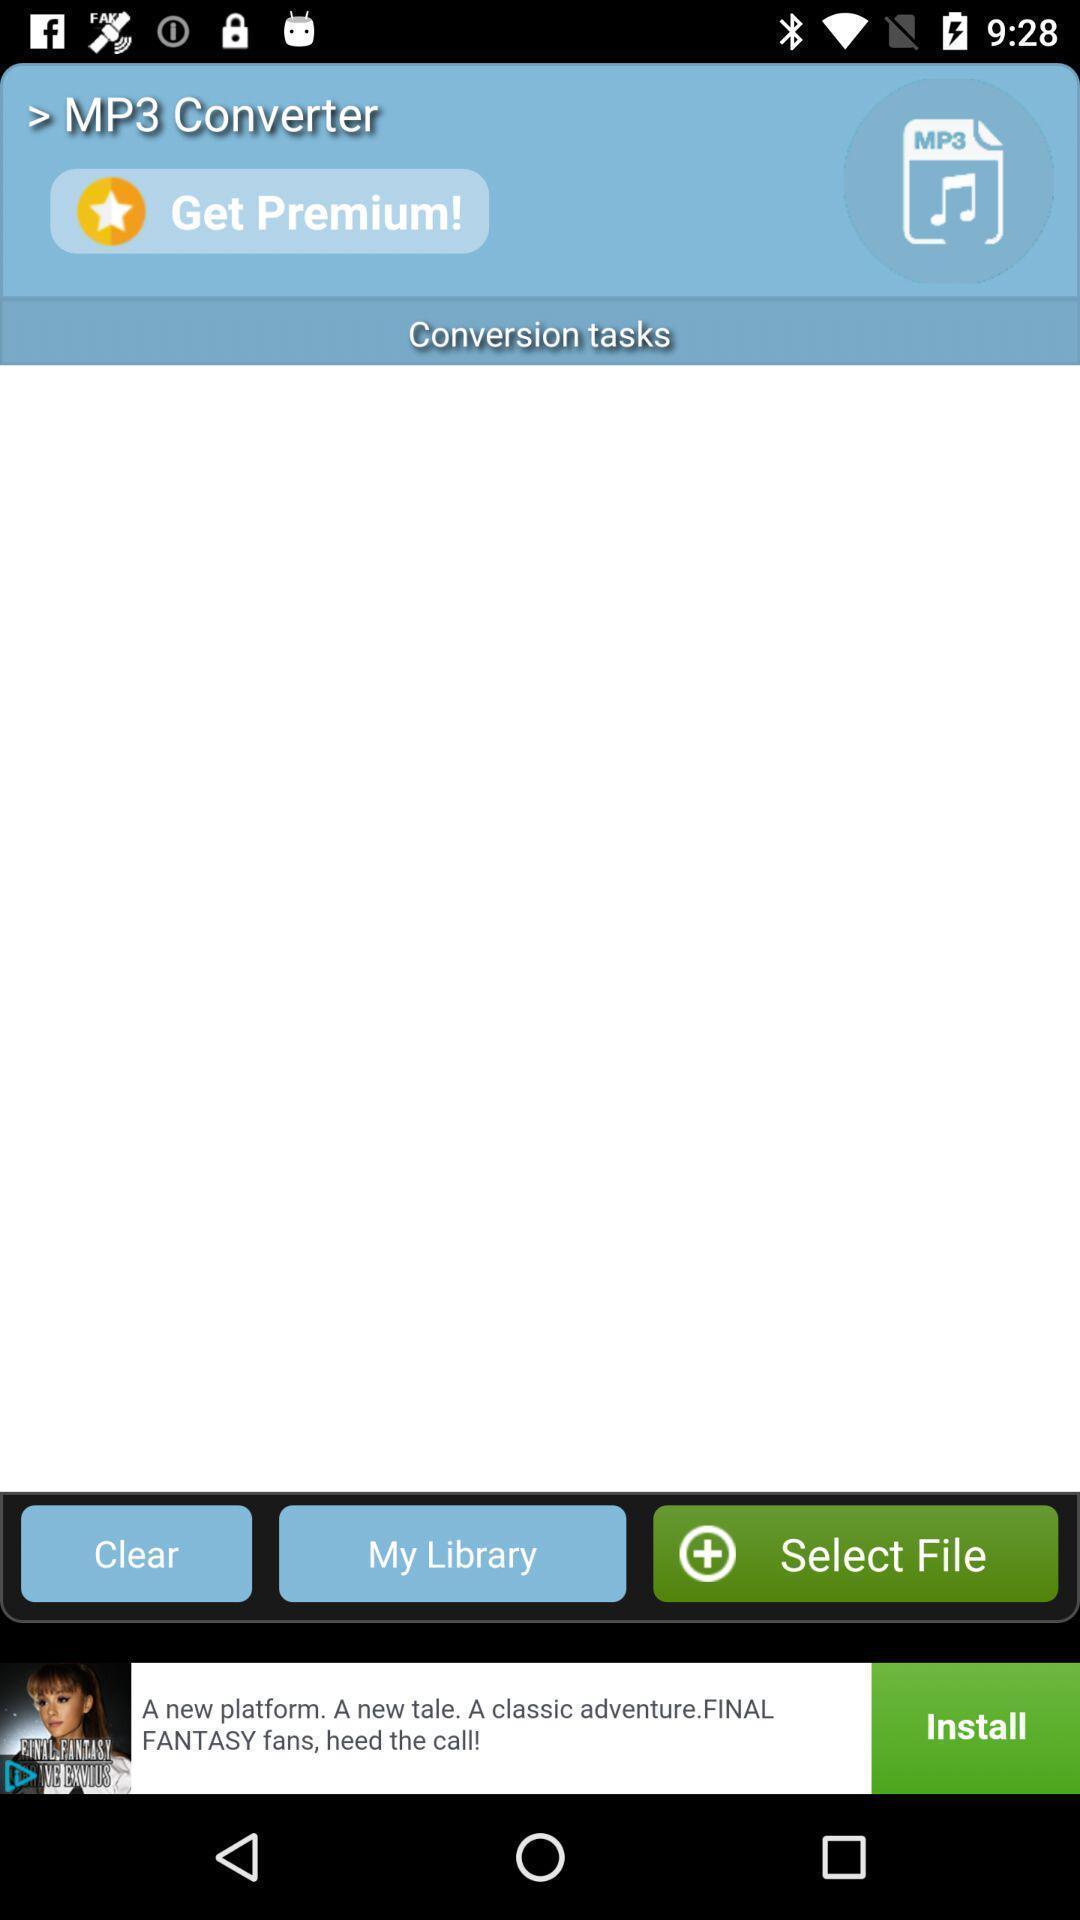Tell me about the visual elements in this screen capture. Screen displaying a music application. 